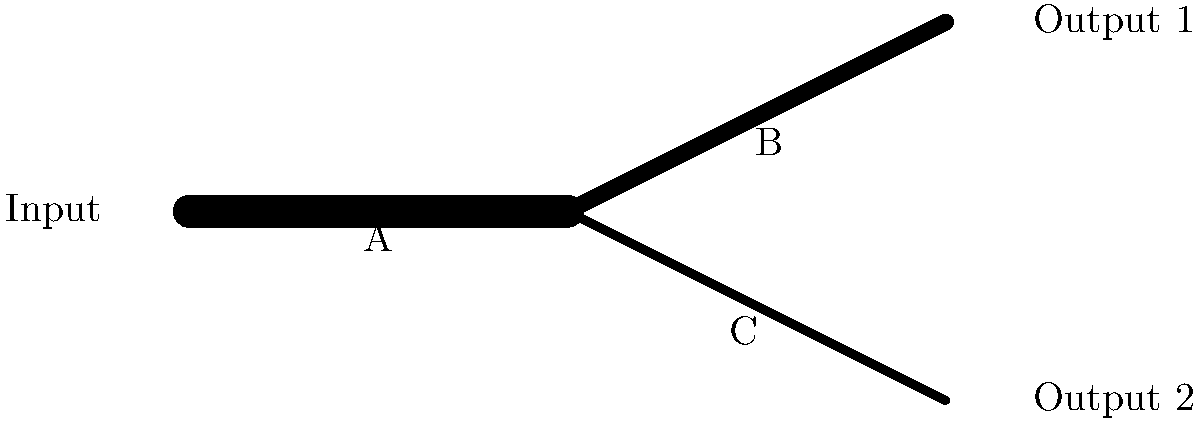In a backend system processing data streams, you're tasked with optimizing the data flow represented by the diagram. Pipe A has a throughput of 1000 MB/s, which splits into pipes B and C. If pipe B has twice the diameter of pipe C, what is the throughput of pipe C in MB/s? To solve this problem, we'll follow these steps:

1. Understand the relationship between pipe diameter and throughput:
   The throughput of a pipe is proportional to its cross-sectional area, which is proportional to the square of its diameter.

2. Set up the ratio of throughputs:
   Let $x$ be the throughput of pipe C.
   Then, the throughput of pipe B is $2^2x = 4x$ (since its diameter is twice that of C).

3. Apply the conservation of data flow:
   The total throughput of pipes B and C should equal the throughput of pipe A.
   $$x + 4x = 1000$$

4. Solve the equation:
   $$5x = 1000$$
   $$x = 1000 / 5 = 200$$

5. Verify the result:
   Pipe C: 200 MB/s
   Pipe B: 4 * 200 = 800 MB/s
   Total: 200 + 800 = 1000 MB/s (matches pipe A)

Therefore, the throughput of pipe C is 200 MB/s.
Answer: 200 MB/s 